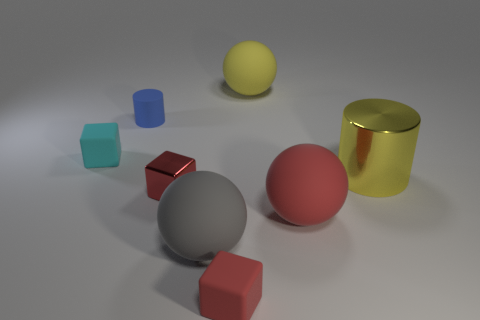How many tiny shiny things have the same color as the big metal thing?
Provide a succinct answer. 0. There is a red matte object that is left of the big red rubber ball; is there a tiny red thing to the left of it?
Offer a very short reply. Yes. There is a sphere right of the yellow rubber sphere; does it have the same color as the shiny object in front of the yellow cylinder?
Give a very brief answer. Yes. What is the color of the metal thing that is the same size as the gray rubber sphere?
Make the answer very short. Yellow. Is the number of big yellow metal things that are on the left side of the big red thing the same as the number of blocks that are to the left of the gray thing?
Keep it short and to the point. No. There is a cylinder to the right of the matte object behind the matte cylinder; what is its material?
Keep it short and to the point. Metal. What number of objects are small cyan matte cylinders or large red matte objects?
Provide a succinct answer. 1. The ball that is the same color as the tiny metal cube is what size?
Your answer should be very brief. Large. Is the number of shiny cylinders less than the number of tiny red cylinders?
Ensure brevity in your answer.  No. What is the size of the other red object that is the same material as the big red thing?
Your response must be concise. Small. 